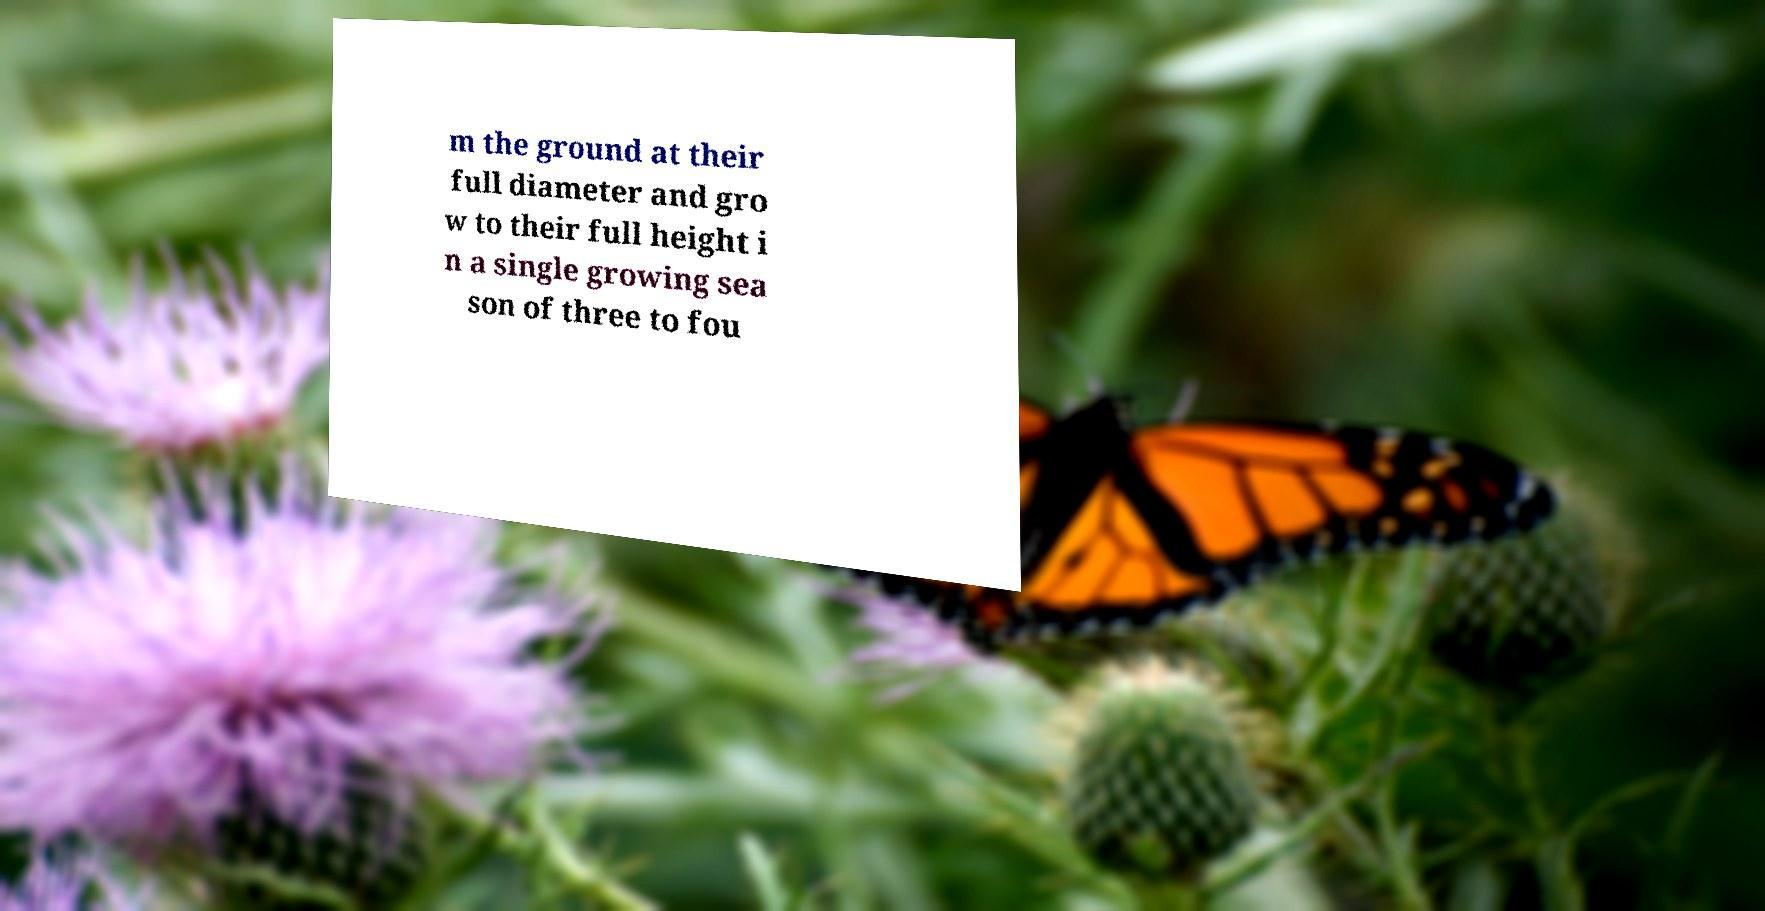Please read and relay the text visible in this image. What does it say? m the ground at their full diameter and gro w to their full height i n a single growing sea son of three to fou 